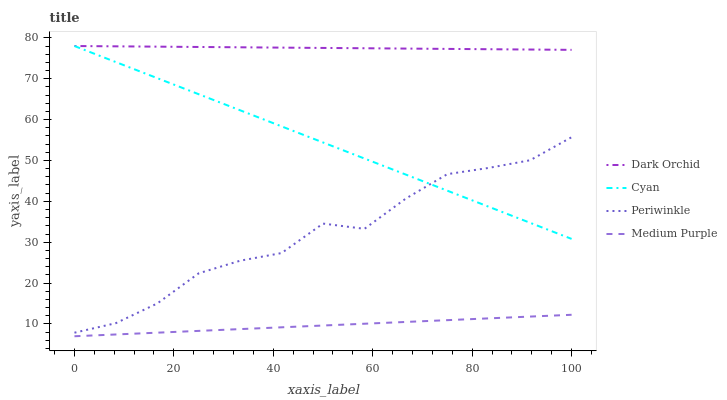Does Medium Purple have the minimum area under the curve?
Answer yes or no. Yes. Does Dark Orchid have the maximum area under the curve?
Answer yes or no. Yes. Does Cyan have the minimum area under the curve?
Answer yes or no. No. Does Cyan have the maximum area under the curve?
Answer yes or no. No. Is Medium Purple the smoothest?
Answer yes or no. Yes. Is Periwinkle the roughest?
Answer yes or no. Yes. Is Cyan the smoothest?
Answer yes or no. No. Is Cyan the roughest?
Answer yes or no. No. Does Medium Purple have the lowest value?
Answer yes or no. Yes. Does Cyan have the lowest value?
Answer yes or no. No. Does Dark Orchid have the highest value?
Answer yes or no. Yes. Does Periwinkle have the highest value?
Answer yes or no. No. Is Medium Purple less than Dark Orchid?
Answer yes or no. Yes. Is Dark Orchid greater than Periwinkle?
Answer yes or no. Yes. Does Cyan intersect Periwinkle?
Answer yes or no. Yes. Is Cyan less than Periwinkle?
Answer yes or no. No. Is Cyan greater than Periwinkle?
Answer yes or no. No. Does Medium Purple intersect Dark Orchid?
Answer yes or no. No. 